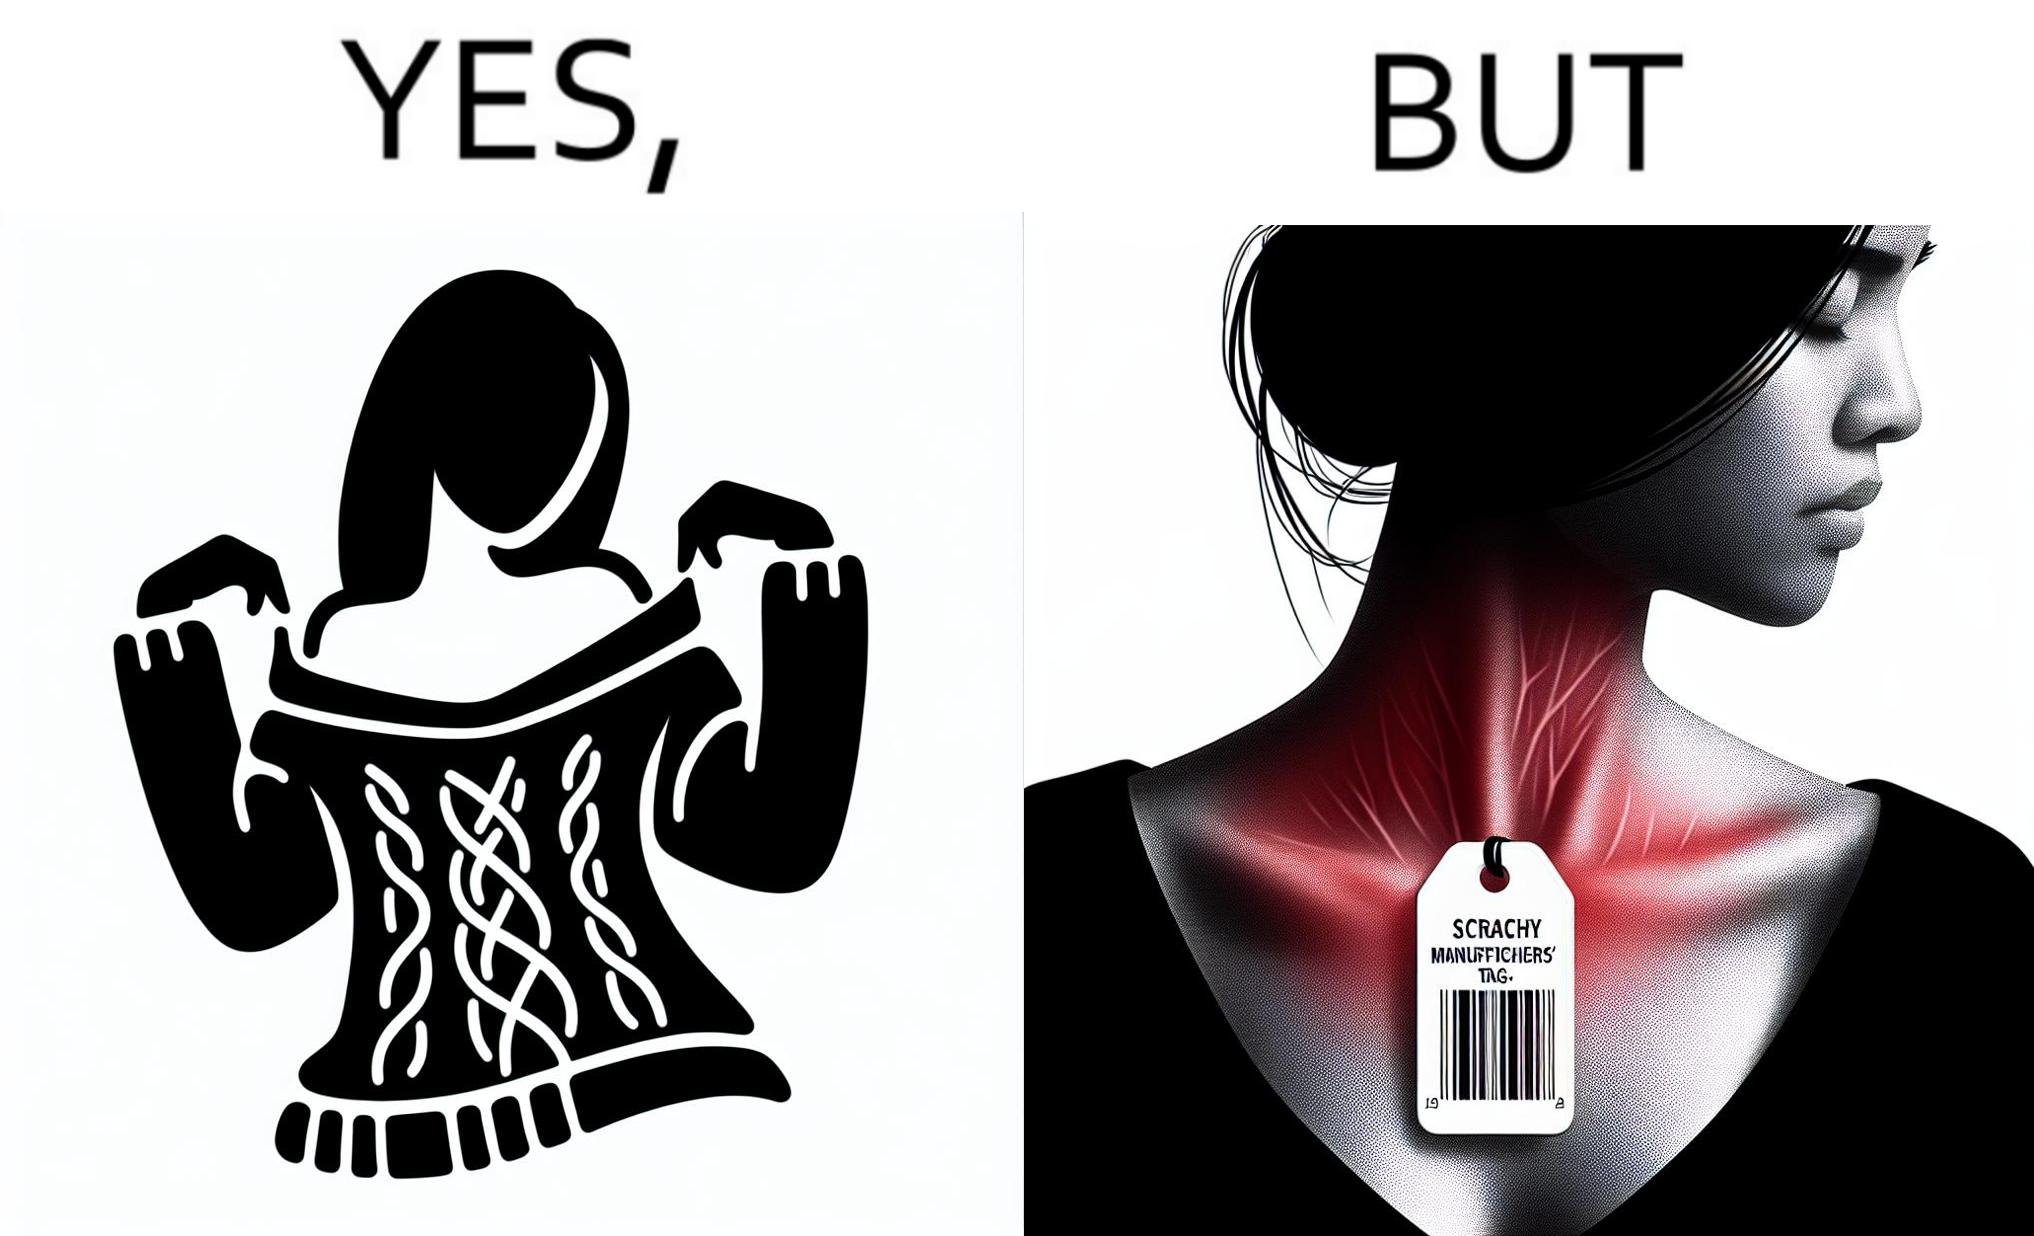Would you classify this image as satirical? Yes, this image is satirical. 